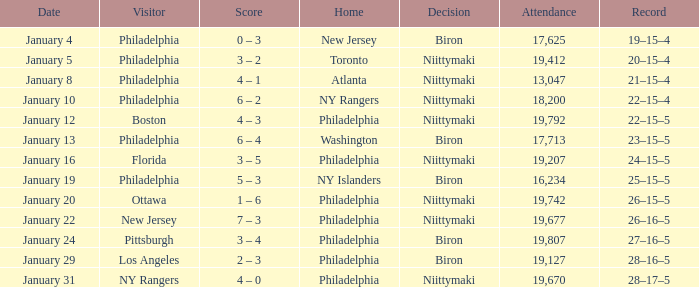What was the date that the decision was Niittymaki, the attendance larger than 19,207, and the record 28–17–5? January 31. 